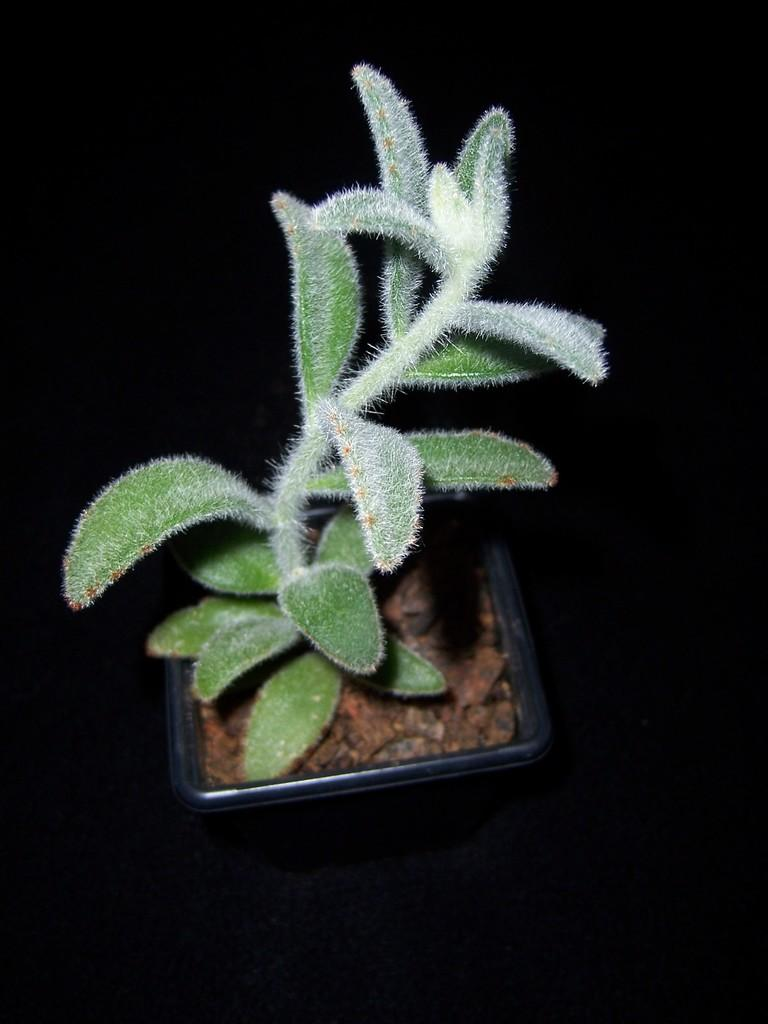What type of plant is in the image? There is a house plant in the image. What can be observed about the lighting in the image? The background of the image is dark. How many geese are flying in the image? There are no geese present in the image. What type of fan is visible in the image? There is no fan present in the image. 